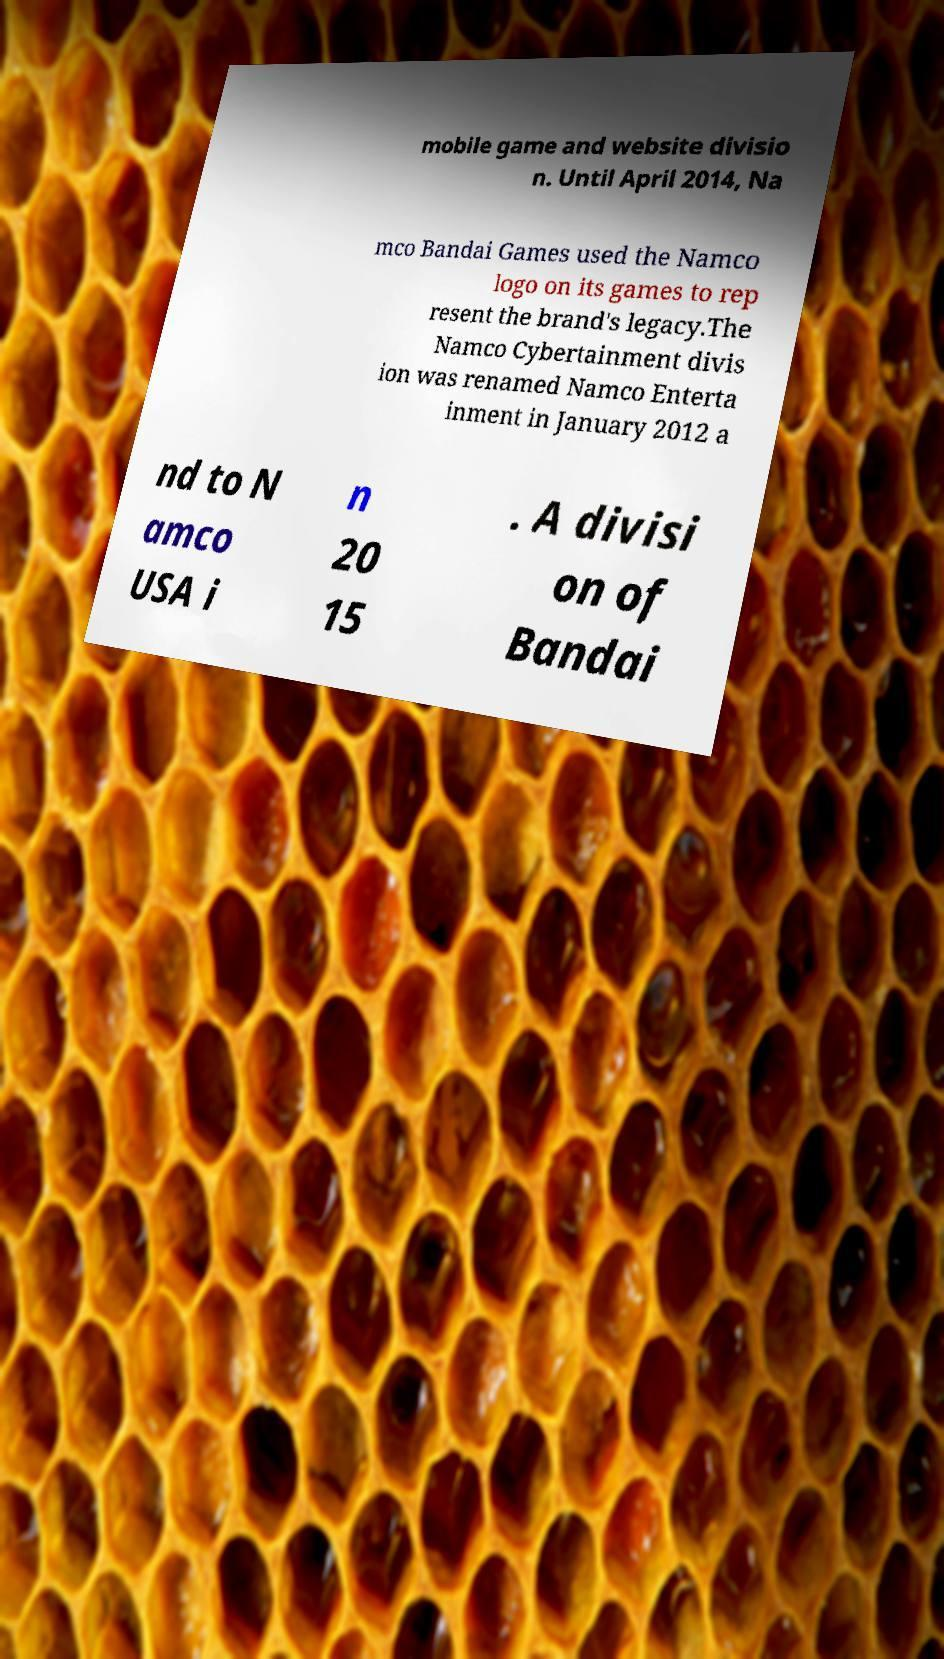I need the written content from this picture converted into text. Can you do that? mobile game and website divisio n. Until April 2014, Na mco Bandai Games used the Namco logo on its games to rep resent the brand's legacy.The Namco Cybertainment divis ion was renamed Namco Enterta inment in January 2012 a nd to N amco USA i n 20 15 . A divisi on of Bandai 